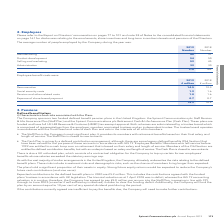According to Spirent Communications Plc's financial document, What should be referred to for disclosures relating to the emoluments, share incentives and long-term incentive interests and pensions of the Directors? refer to the Report on Directors’ remuneration on pages 77 to 101 and note 38 of Notes to the consolidated financial statements on page 161. The document states: "2. Employees Please refer to the Report on Directors’ remuneration on pages 77 to 101 and note 38 of Notes to the consolidated financial statements on..." Also, What was the average number of people employed by the Company in 2019? According to the financial document, 178. The relevant text states: "178 162..." Also, What are the different departments for which the average number of people were employed by the Company during the year was recorded? The document contains multiple relevant values: Manufacturing, Product development, Selling and marketing, Administration. From the document: "Manufacturing 40 37 Administration 32 30 Product development 54 50 Selling and marketing 52 45..." Additionally, In which year was the number of employees in Selling and marketing higher? According to the financial document, 2019. The relevant text states: "173 Spirent Communications plc Annual Report 2019..." Also, can you calculate: What was the change in the average number of people employed by the company in 2019? Based on the calculation: 178-162, the result is 16. This is based on the information: "178 162 178 162..." The key data points involved are: 162, 178. Also, can you calculate: What was the percentage change in the average number of people employed by the company in 2019? To answer this question, I need to perform calculations using the financial data. The calculation is: (178-162)/162, which equals 9.88 (percentage). This is based on the information: "178 162 178 162..." The key data points involved are: 162, 178. 